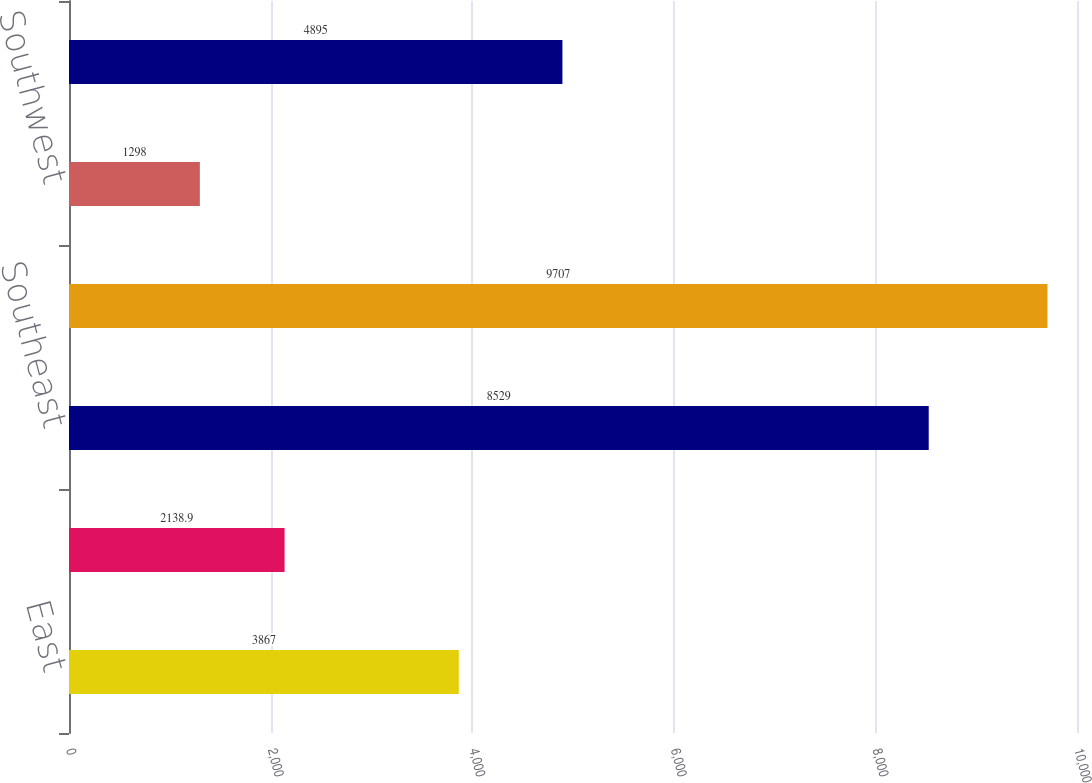Convert chart. <chart><loc_0><loc_0><loc_500><loc_500><bar_chart><fcel>East<fcel>Midwest<fcel>Southeast<fcel>South Central<fcel>Southwest<fcel>West<nl><fcel>3867<fcel>2138.9<fcel>8529<fcel>9707<fcel>1298<fcel>4895<nl></chart> 